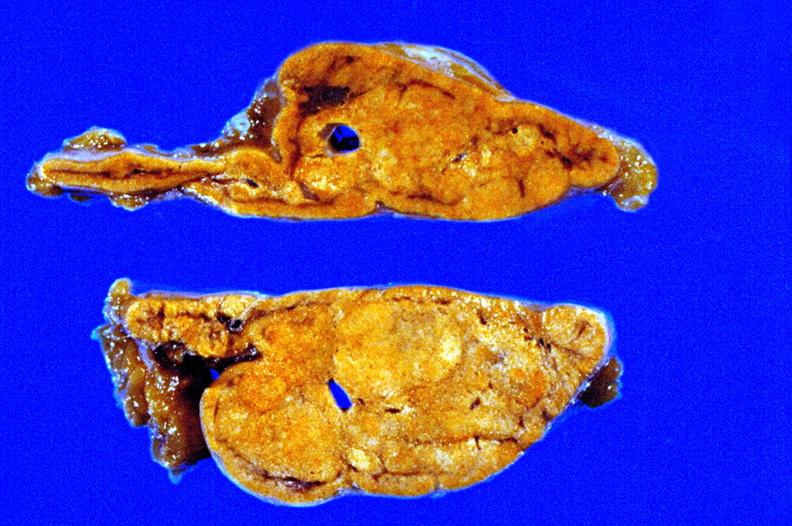s fixed tissue cut surface close-up view rather good apparently non-functional?
Answer the question using a single word or phrase. Yes 